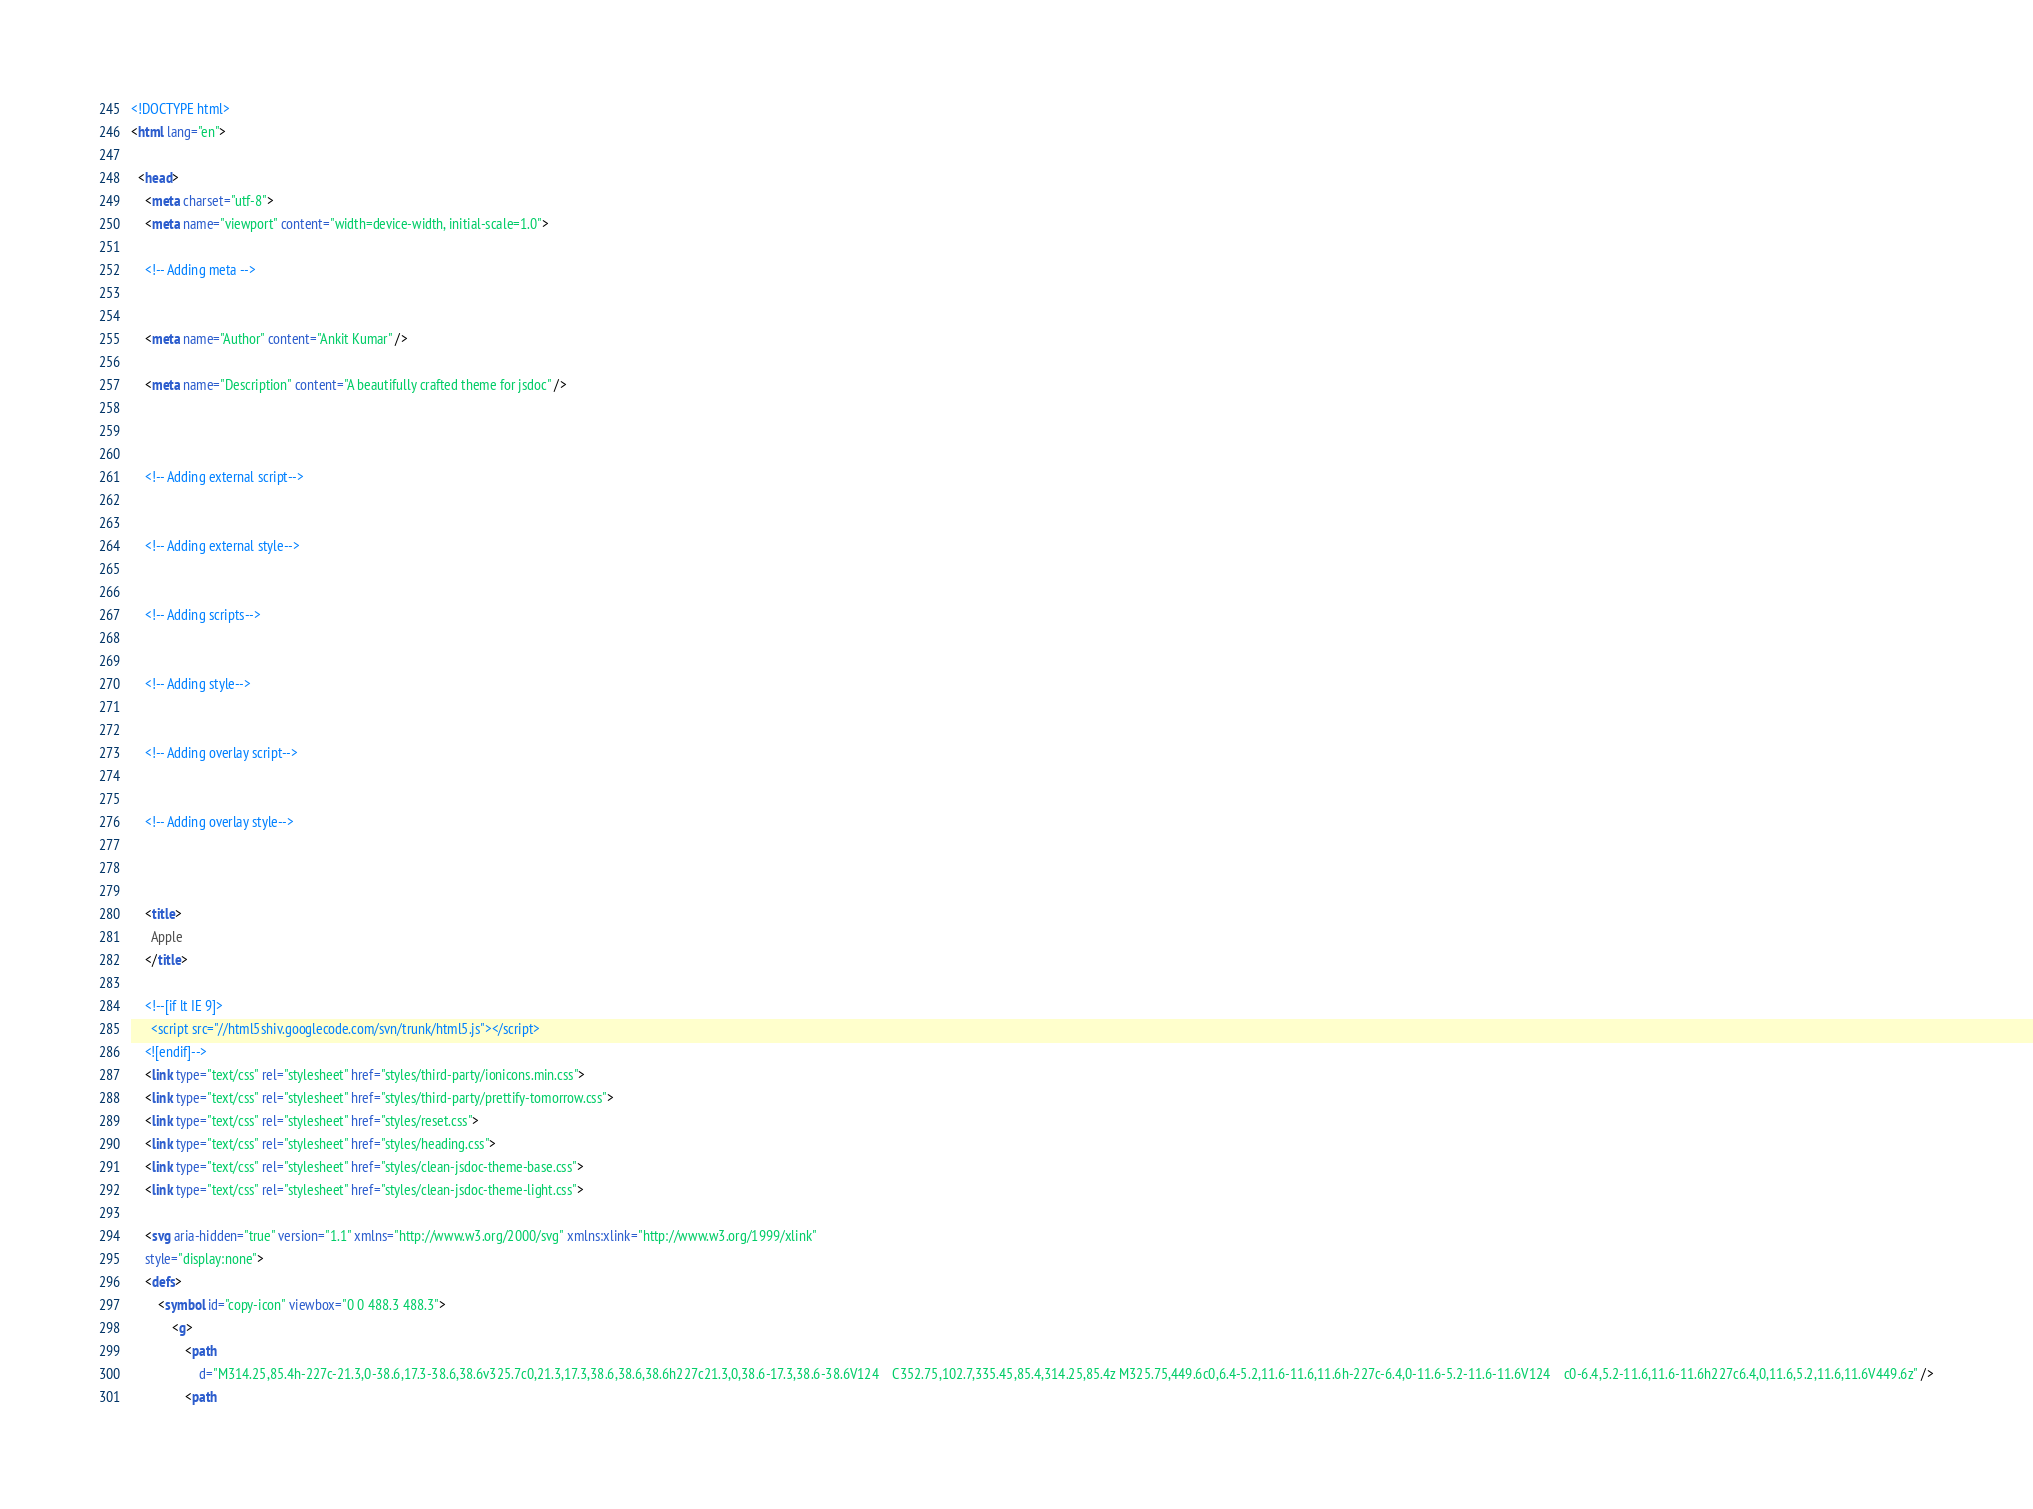<code> <loc_0><loc_0><loc_500><loc_500><_HTML_><!DOCTYPE html>
<html lang="en">

  <head>
    <meta charset="utf-8">
    <meta name="viewport" content="width=device-width, initial-scale=1.0">

    <!-- Adding meta -->
    
    
    <meta name="Author" content="Ankit Kumar" />
    
    <meta name="Description" content="A beautifully crafted theme for jsdoc" />
    
    

    <!-- Adding external script-->
    

    <!-- Adding external style-->
    

    <!-- Adding scripts-->
    

    <!-- Adding style-->
    

    <!-- Adding overlay script-->
    

    <!-- Adding overlay style-->
    


    <title>
      Apple
    </title>

    <!--[if lt IE 9]>
      <script src="//html5shiv.googlecode.com/svn/trunk/html5.js"></script>
    <![endif]-->
    <link type="text/css" rel="stylesheet" href="styles/third-party/ionicons.min.css">
    <link type="text/css" rel="stylesheet" href="styles/third-party/prettify-tomorrow.css">
    <link type="text/css" rel="stylesheet" href="styles/reset.css">
    <link type="text/css" rel="stylesheet" href="styles/heading.css">
    <link type="text/css" rel="stylesheet" href="styles/clean-jsdoc-theme-base.css">
    <link type="text/css" rel="stylesheet" href="styles/clean-jsdoc-theme-light.css">
    
    <svg aria-hidden="true" version="1.1" xmlns="http://www.w3.org/2000/svg" xmlns:xlink="http://www.w3.org/1999/xlink"
    style="display:none">
    <defs>
        <symbol id="copy-icon" viewbox="0 0 488.3 488.3">
            <g>
                <path
                    d="M314.25,85.4h-227c-21.3,0-38.6,17.3-38.6,38.6v325.7c0,21.3,17.3,38.6,38.6,38.6h227c21.3,0,38.6-17.3,38.6-38.6V124    C352.75,102.7,335.45,85.4,314.25,85.4z M325.75,449.6c0,6.4-5.2,11.6-11.6,11.6h-227c-6.4,0-11.6-5.2-11.6-11.6V124    c0-6.4,5.2-11.6,11.6-11.6h227c6.4,0,11.6,5.2,11.6,11.6V449.6z" />
                <path</code> 